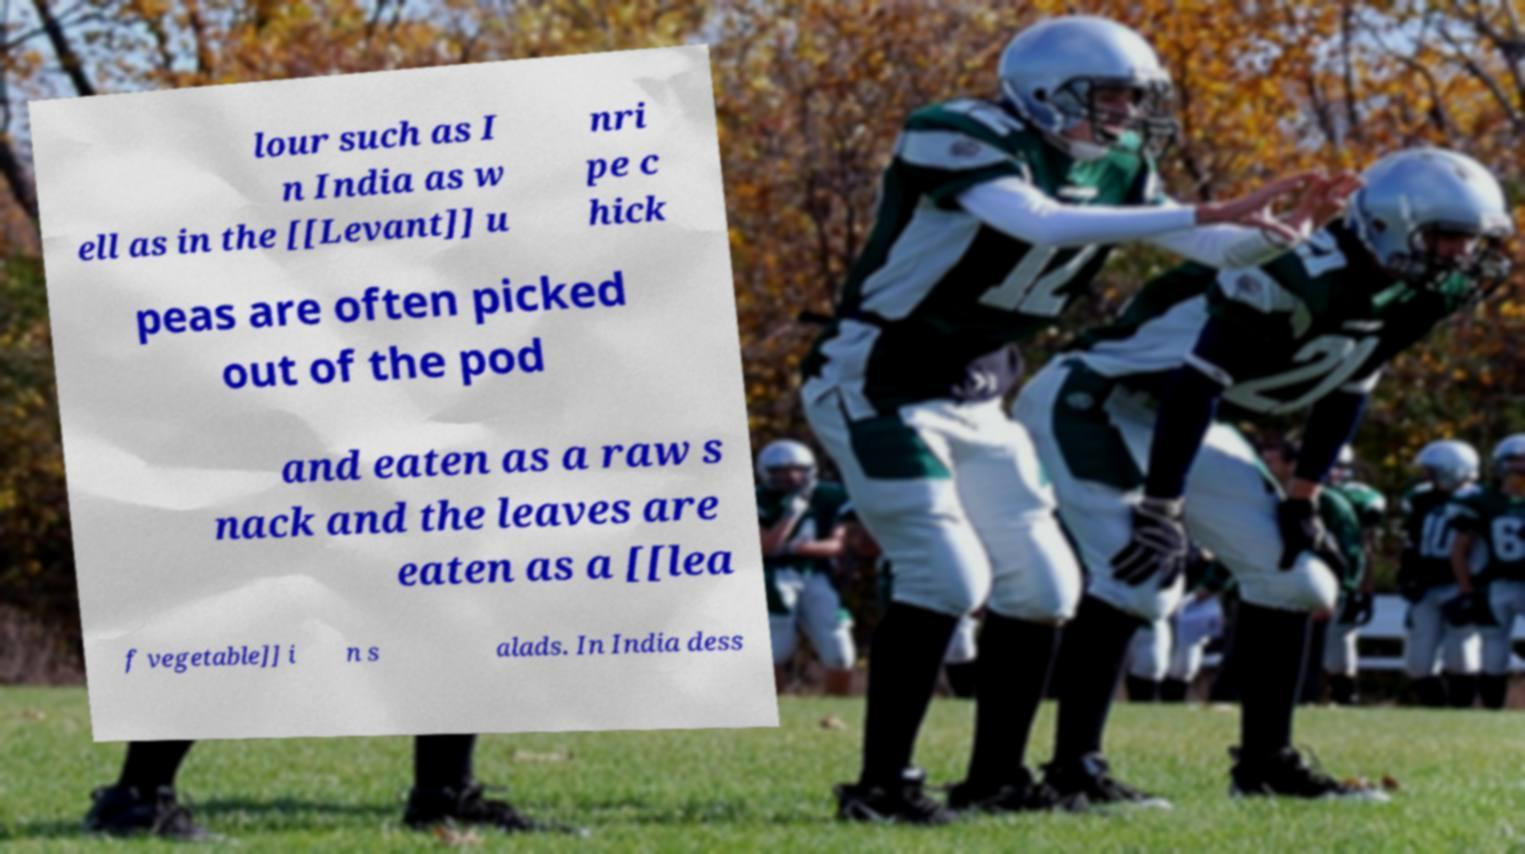Please read and relay the text visible in this image. What does it say? lour such as I n India as w ell as in the [[Levant]] u nri pe c hick peas are often picked out of the pod and eaten as a raw s nack and the leaves are eaten as a [[lea f vegetable]] i n s alads. In India dess 